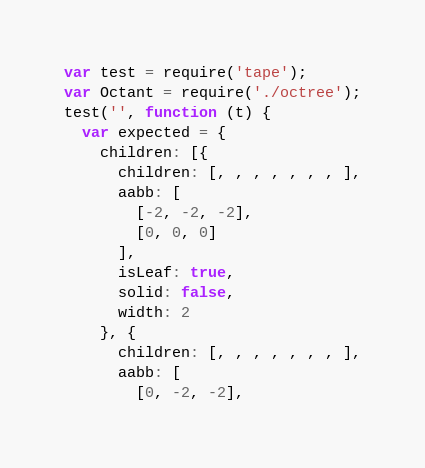<code> <loc_0><loc_0><loc_500><loc_500><_JavaScript_>var test = require('tape');
var Octant = require('./octree');
test('', function (t) {
  var expected = {
    children: [{
      children: [, , , , , , , ],
      aabb: [
        [-2, -2, -2],
        [0, 0, 0]
      ],
      isLeaf: true,
      solid: false,
      width: 2
    }, {
      children: [, , , , , , , ],
      aabb: [
        [0, -2, -2],</code> 